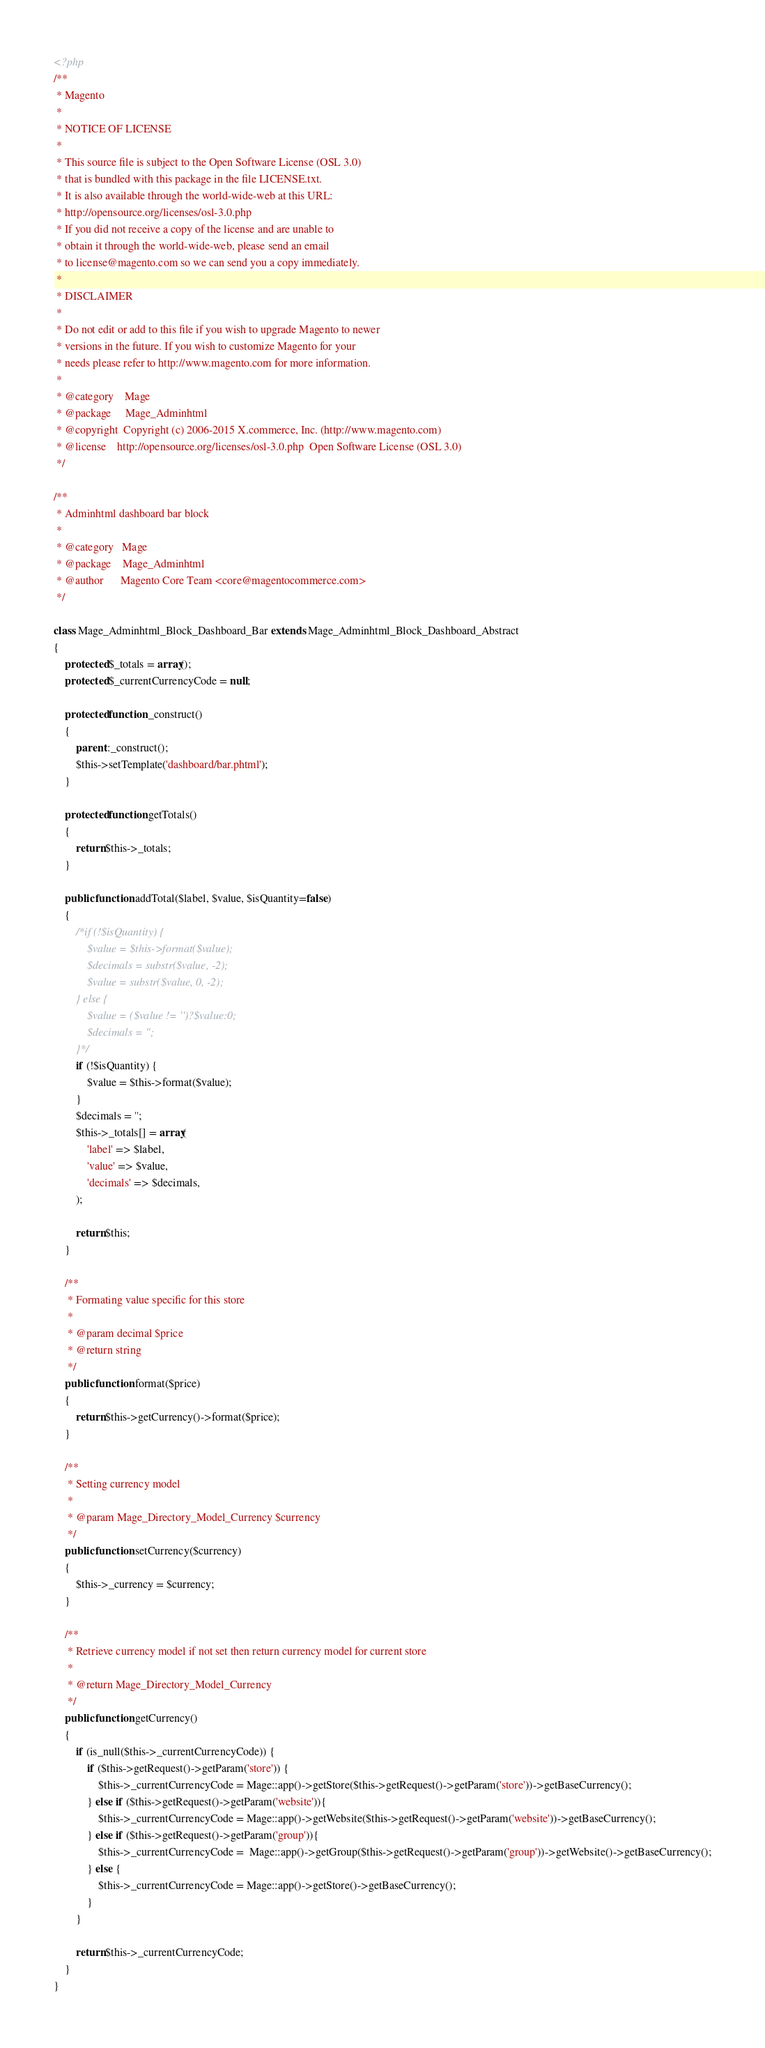Convert code to text. <code><loc_0><loc_0><loc_500><loc_500><_PHP_><?php
/**
 * Magento
 *
 * NOTICE OF LICENSE
 *
 * This source file is subject to the Open Software License (OSL 3.0)
 * that is bundled with this package in the file LICENSE.txt.
 * It is also available through the world-wide-web at this URL:
 * http://opensource.org/licenses/osl-3.0.php
 * If you did not receive a copy of the license and are unable to
 * obtain it through the world-wide-web, please send an email
 * to license@magento.com so we can send you a copy immediately.
 *
 * DISCLAIMER
 *
 * Do not edit or add to this file if you wish to upgrade Magento to newer
 * versions in the future. If you wish to customize Magento for your
 * needs please refer to http://www.magento.com for more information.
 *
 * @category    Mage
 * @package     Mage_Adminhtml
 * @copyright  Copyright (c) 2006-2015 X.commerce, Inc. (http://www.magento.com)
 * @license    http://opensource.org/licenses/osl-3.0.php  Open Software License (OSL 3.0)
 */

/**
 * Adminhtml dashboard bar block
 *
 * @category   Mage
 * @package    Mage_Adminhtml
 * @author      Magento Core Team <core@magentocommerce.com>
 */

class Mage_Adminhtml_Block_Dashboard_Bar extends Mage_Adminhtml_Block_Dashboard_Abstract
{
    protected $_totals = array();
    protected $_currentCurrencyCode = null;

    protected function _construct()
    {
        parent::_construct();
        $this->setTemplate('dashboard/bar.phtml');
    }

    protected function getTotals()
    {
        return $this->_totals;
    }

    public function addTotal($label, $value, $isQuantity=false)
    {
        /*if (!$isQuantity) {
            $value = $this->format($value);
            $decimals = substr($value, -2);
            $value = substr($value, 0, -2);
        } else {
            $value = ($value != '')?$value:0;
            $decimals = '';
        }*/
        if (!$isQuantity) {
            $value = $this->format($value);
        }
        $decimals = '';
        $this->_totals[] = array(
            'label' => $label,
            'value' => $value,
            'decimals' => $decimals,
        );

        return $this;
    }

    /**
     * Formating value specific for this store
     *
     * @param decimal $price
     * @return string
     */
    public function format($price)
    {
        return $this->getCurrency()->format($price);
    }

    /**
     * Setting currency model
     *
     * @param Mage_Directory_Model_Currency $currency
     */
    public function setCurrency($currency)
    {
        $this->_currency = $currency;
    }

    /**
     * Retrieve currency model if not set then return currency model for current store
     *
     * @return Mage_Directory_Model_Currency
     */
    public function getCurrency()
    {
        if (is_null($this->_currentCurrencyCode)) {
            if ($this->getRequest()->getParam('store')) {
                $this->_currentCurrencyCode = Mage::app()->getStore($this->getRequest()->getParam('store'))->getBaseCurrency();
            } else if ($this->getRequest()->getParam('website')){
                $this->_currentCurrencyCode = Mage::app()->getWebsite($this->getRequest()->getParam('website'))->getBaseCurrency();
            } else if ($this->getRequest()->getParam('group')){
                $this->_currentCurrencyCode =  Mage::app()->getGroup($this->getRequest()->getParam('group'))->getWebsite()->getBaseCurrency();
            } else {
                $this->_currentCurrencyCode = Mage::app()->getStore()->getBaseCurrency();
            }
        }

        return $this->_currentCurrencyCode;
    }
}
</code> 